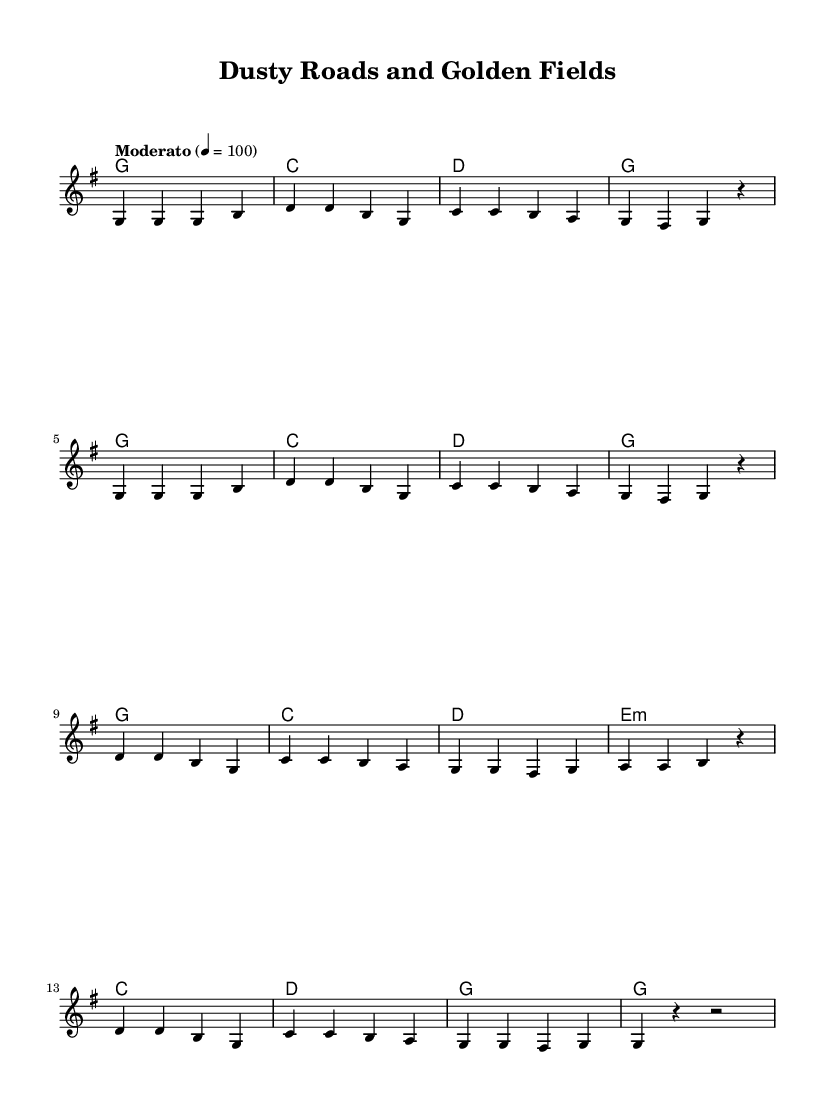What is the key signature of this music? The key signature is G major, which has one sharp (F#). This can be identified at the beginning of the sheet music where the key signature is indicated.
Answer: G major What is the time signature of this music? The time signature is 4/4, which means there are four beats in each measure and the quarter note gets one beat. This is written at the beginning of the score.
Answer: 4/4 What is the tempo marking for this piece? The tempo marking is "Moderato," indicating a moderate speed. This can be found next to the tempo indication at the start of the score.
Answer: Moderato What is the first chord in the verse? The first chord in the verse is G major. It can be seen in the harmonies section above the melody, indicating the chord played during the first measure of the verse.
Answer: G How many measures are in the chorus? There are eight measures in the chorus, which can be counted directly from the melody and harmonies sections, as each segment is separated by a bar line.
Answer: 8 What is the theme of the lyrics in the song? The theme of the lyrics revolves around celebrating the heritage and culture of small-town Australia, as seen in phrases like "stories whisper" and "heritage shines like gold." This understanding is derived from analyzing the verses and chorus of the lyrics.
Answer: Heritage and culture What is the last note of the chorus? The last note of the chorus is a rest, as indicated by the 'r' notation in the melody at the end of measure 8 of the chorus.
Answer: Rest 